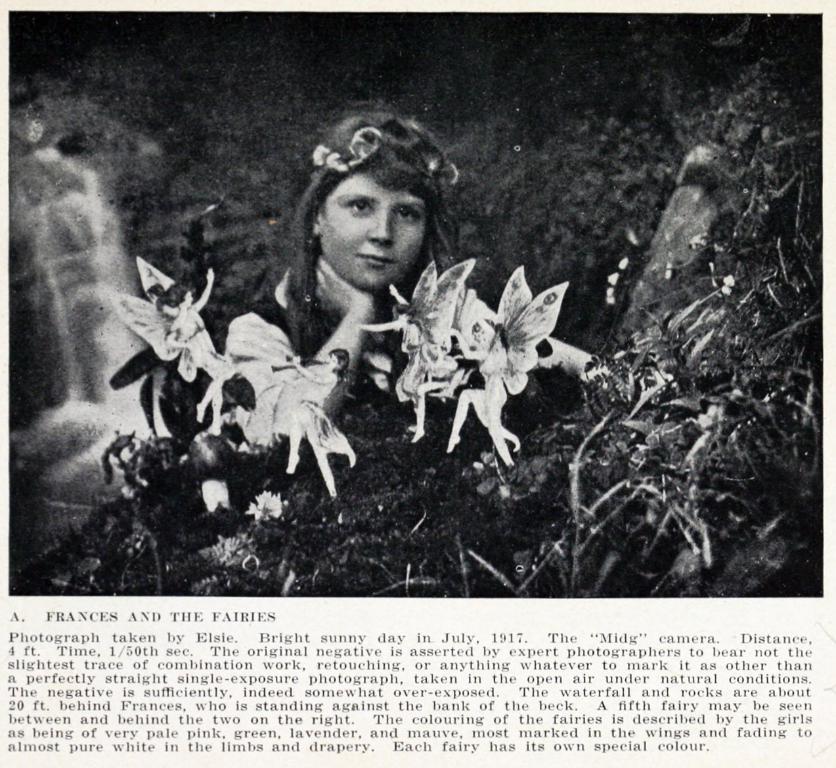Could you give a brief overview of what you see in this image? At the top of the image there is a picture with a girl and in front of her there are fairies on the ground. At the left corner of the image there is water fall. At the bottom of the image there is a paragraph. 